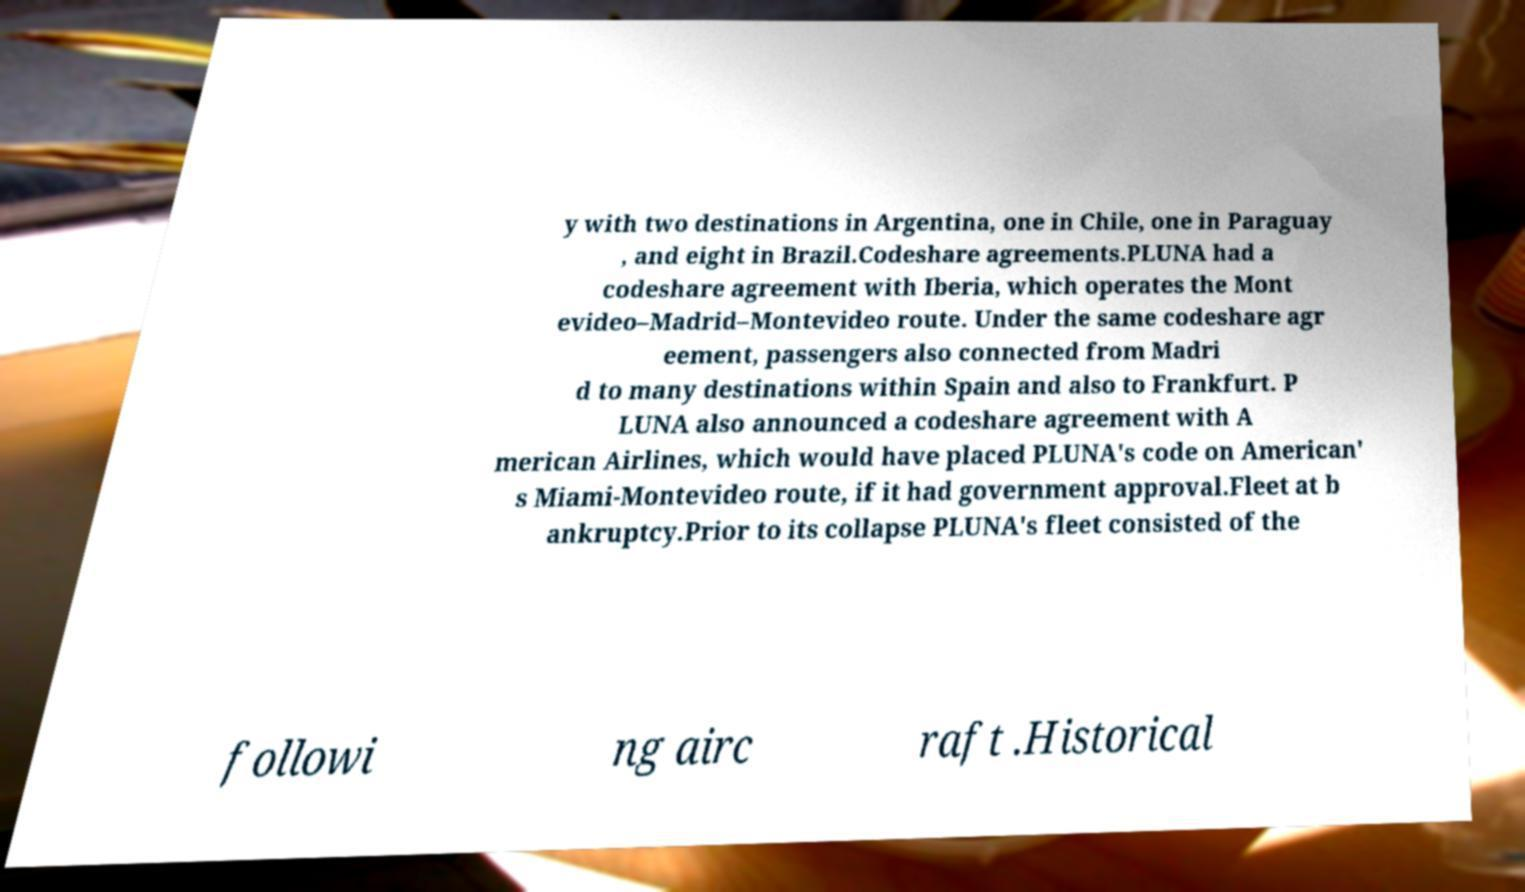Please identify and transcribe the text found in this image. y with two destinations in Argentina, one in Chile, one in Paraguay , and eight in Brazil.Codeshare agreements.PLUNA had a codeshare agreement with Iberia, which operates the Mont evideo–Madrid–Montevideo route. Under the same codeshare agr eement, passengers also connected from Madri d to many destinations within Spain and also to Frankfurt. P LUNA also announced a codeshare agreement with A merican Airlines, which would have placed PLUNA's code on American' s Miami-Montevideo route, if it had government approval.Fleet at b ankruptcy.Prior to its collapse PLUNA's fleet consisted of the followi ng airc raft .Historical 